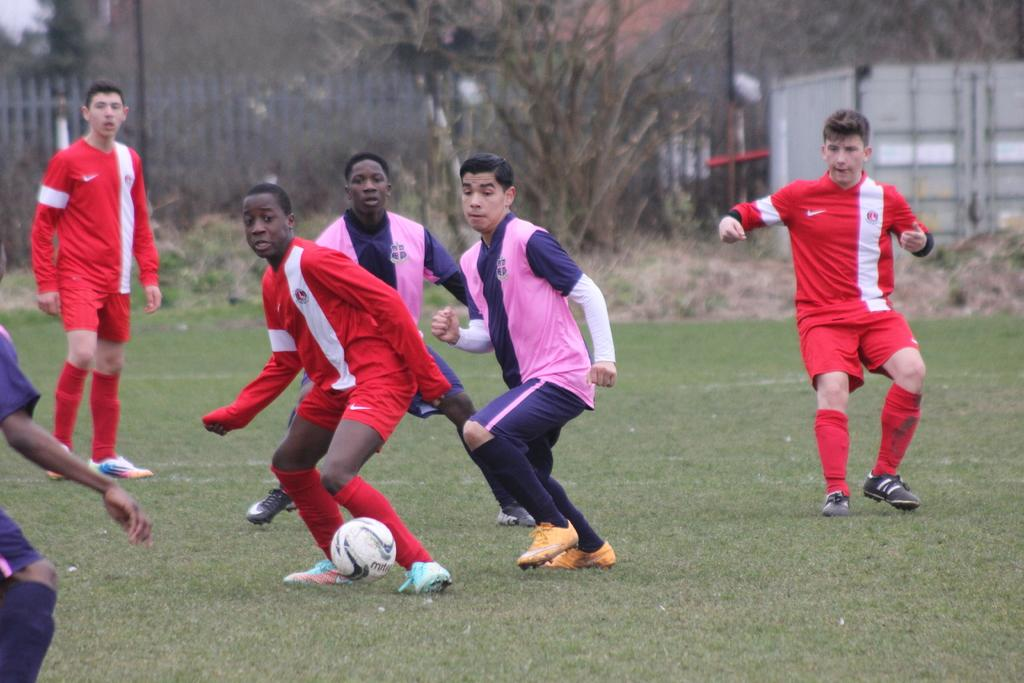What are the people in the image doing? The people are playing football in the image. What type of surface are they playing on? The ground is green and likely to be a grassy field. What can be seen in the background of the image? There are trees in the background of the image. What type of thrill can be felt by the people playing football in the image? The image does not convey any information about the feelings or emotions of the people playing football, so it is not possible to determine the type of thrill they might be experiencing. 